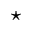Convert formula to latex. <formula><loc_0><loc_0><loc_500><loc_500>^ { ^ { * } }</formula> 